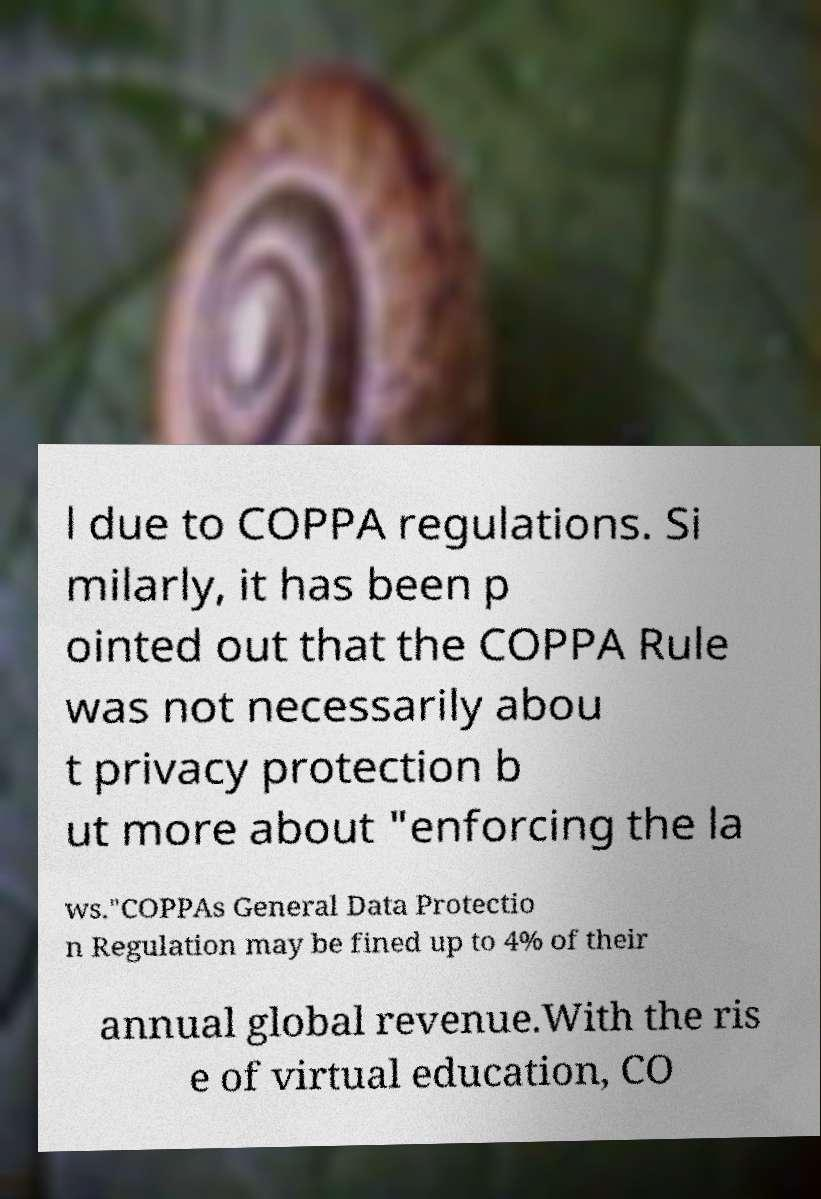Please read and relay the text visible in this image. What does it say? l due to COPPA regulations. Si milarly, it has been p ointed out that the COPPA Rule was not necessarily abou t privacy protection b ut more about "enforcing the la ws."COPPAs General Data Protectio n Regulation may be fined up to 4% of their annual global revenue.With the ris e of virtual education, CO 